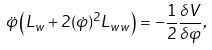<formula> <loc_0><loc_0><loc_500><loc_500>\ddot { \varphi } \left ( L _ { w } + 2 ( \dot { \varphi } ) ^ { 2 } L _ { w w } \right ) = - \frac { 1 } { 2 } \frac { \delta V } { \delta \varphi } ,</formula> 